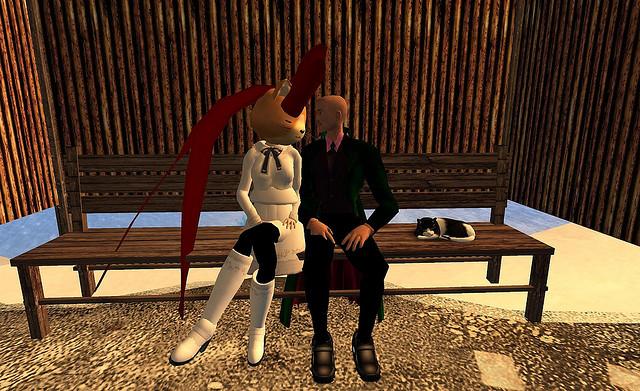Are those humans?
Short answer required. No. What type of animal is pictured?
Keep it brief. Cat. Is there a shadow?
Answer briefly. No. 